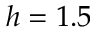<formula> <loc_0><loc_0><loc_500><loc_500>h = 1 . 5</formula> 